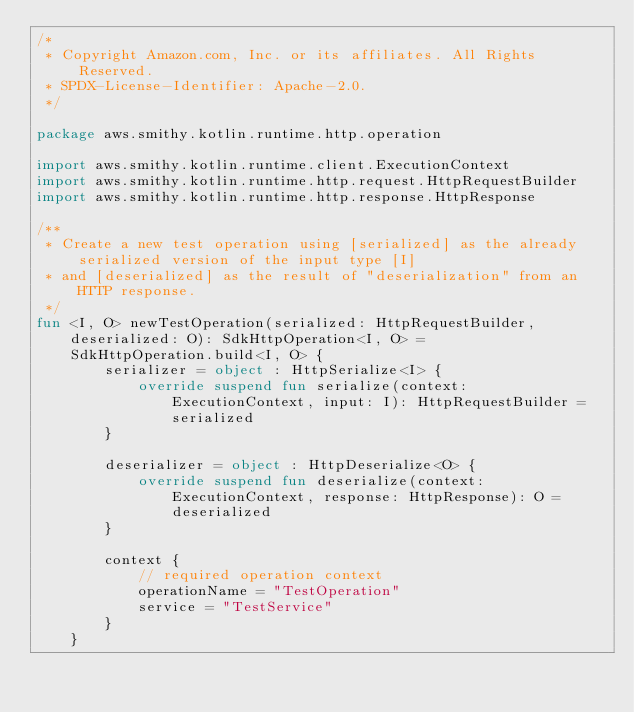<code> <loc_0><loc_0><loc_500><loc_500><_Kotlin_>/*
 * Copyright Amazon.com, Inc. or its affiliates. All Rights Reserved.
 * SPDX-License-Identifier: Apache-2.0.
 */

package aws.smithy.kotlin.runtime.http.operation

import aws.smithy.kotlin.runtime.client.ExecutionContext
import aws.smithy.kotlin.runtime.http.request.HttpRequestBuilder
import aws.smithy.kotlin.runtime.http.response.HttpResponse

/**
 * Create a new test operation using [serialized] as the already serialized version of the input type [I]
 * and [deserialized] as the result of "deserialization" from an HTTP response.
 */
fun <I, O> newTestOperation(serialized: HttpRequestBuilder, deserialized: O): SdkHttpOperation<I, O> =
    SdkHttpOperation.build<I, O> {
        serializer = object : HttpSerialize<I> {
            override suspend fun serialize(context: ExecutionContext, input: I): HttpRequestBuilder = serialized
        }

        deserializer = object : HttpDeserialize<O> {
            override suspend fun deserialize(context: ExecutionContext, response: HttpResponse): O = deserialized
        }

        context {
            // required operation context
            operationName = "TestOperation"
            service = "TestService"
        }
    }
</code> 